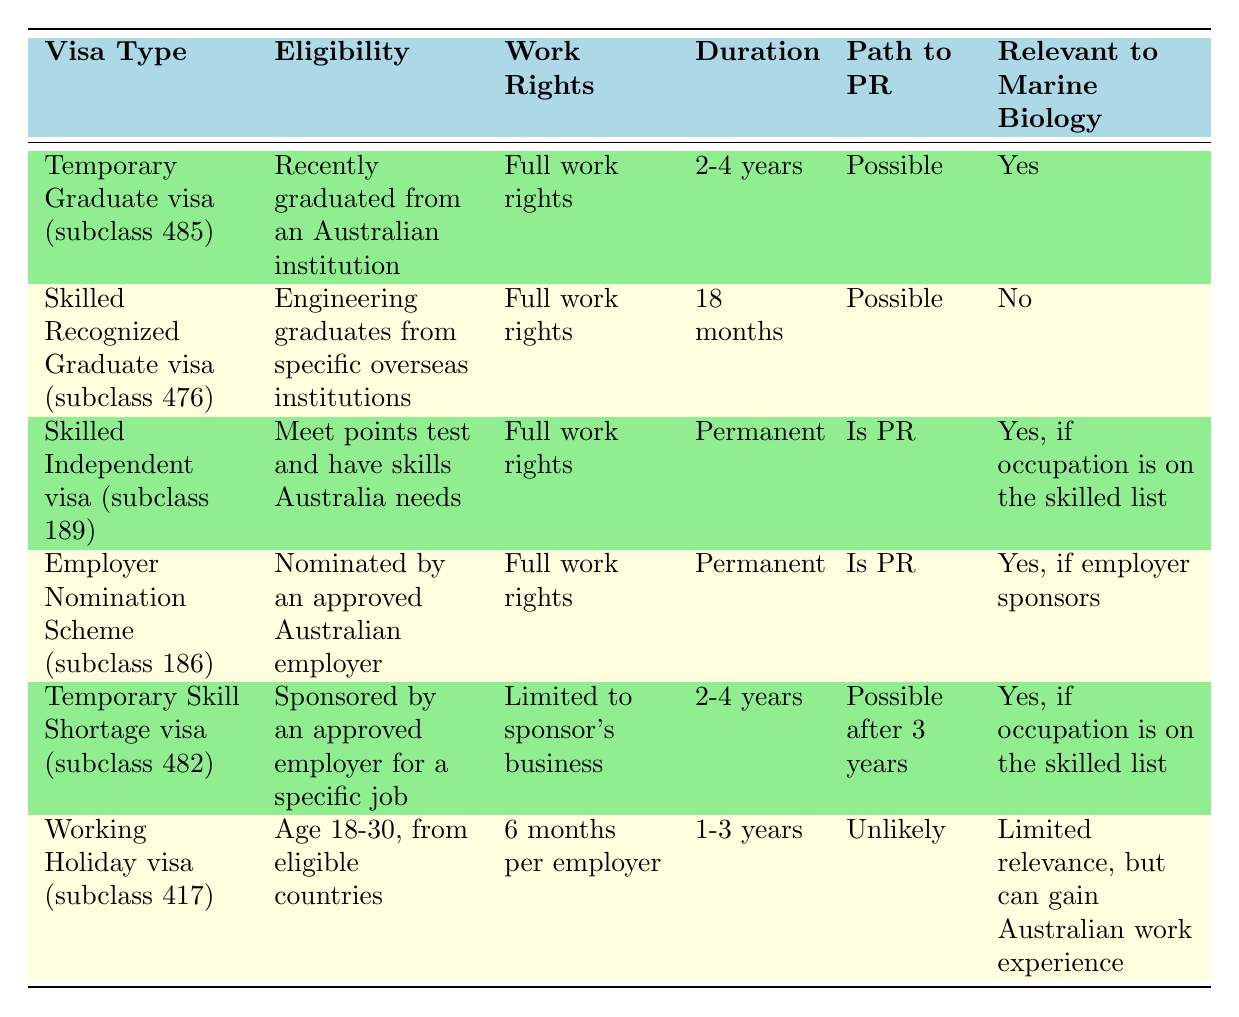What is the duration of the Temporary Graduate visa (subclass 485)? The table indicates that the duration of the Temporary Graduate visa (subclass 485) is specified in the "Duration" column next to its type. This value is 2-4 years.
Answer: 2-4 years Which visa option has full work rights and is relevant to marine biology? By examining the "Work Rights" and "Relevant to Marine Biology" columns, I can see that both the Temporary Graduate visa (subclass 485) and the Skilled Independent visa (subclass 189) have full work rights and are relevant to marine biology.
Answer: Temporary Graduate visa (subclass 485) and Skilled Independent visa (subclass 189) Is the Working Holiday visa (subclass 417) likely to lead to permanent residency? The table shows that the "Path to PR" for the Working Holiday visa (subclass 417) is marked as "Unlikely." This indicates that there is limited potential for this visa to lead to permanent residency.
Answer: No How many visa options offer a path to permanent residency? I will look at the "Path to PR" column for each visa option. The visas that state "Is PR" or "Possible" are the Skilled Independent visa (subclass 189), Employer Nomination Scheme (subclass 186), and Temporary Skill Shortage visa (subclass 482). This results in three options that offer a path to permanent residency.
Answer: 3 visa options Which visa has the shortest duration and does not relate to marine biology? From the duration values in the table, the Skilled Recognized Graduate visa (subclass 476) has a duration of 18 months, and it is noted that it is not relevant to marine biology. This is the shortest duration among the options listed.
Answer: Skilled Recognized Graduate visa (subclass 476) What is the work rights status of the Temporary Skill Shortage visa (subclass 482)? According to the "Work Rights" column, the Temporary Skill Shortage visa (subclass 482) has work rights that are "Limited to sponsor's business." This is a crucial detail regarding this visa's conditions.
Answer: Limited to sponsor's business If an international student graduates in marine biology, which visa should they consider for full work rights and a pathway to permanent residency? The best options are the Temporary Graduate visa (subclass 485) and the Skilled Independent visa (subclass 189). Both offer full work rights and are relevant to marine biology, with the Skilled Independent visa providing a direct path to permanent residency. Hence, they should consider applying for either visa.
Answer: Temporary Graduate visa (subclass 485) or Skilled Independent visa (subclass 189) How do the durations of the Temporary Graduate visa (subclass 485) and the Temporary Skill Shortage visa (subclass 482) compare? The Temporary Graduate visa (subclass 485) lasts for 2-4 years, while the Temporary Skill Shortage visa (subclass 482) also lasts for 2-4 years. They have equivalent durations, thus neither is longer or shorter than the other.
Answer: They are equivalent (2-4 years) 